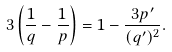<formula> <loc_0><loc_0><loc_500><loc_500>3 \left ( \frac { 1 } { q } - \frac { 1 } { p } \right ) = 1 - \frac { 3 p ^ { \prime } } { ( q ^ { \prime } ) ^ { 2 } } .</formula> 